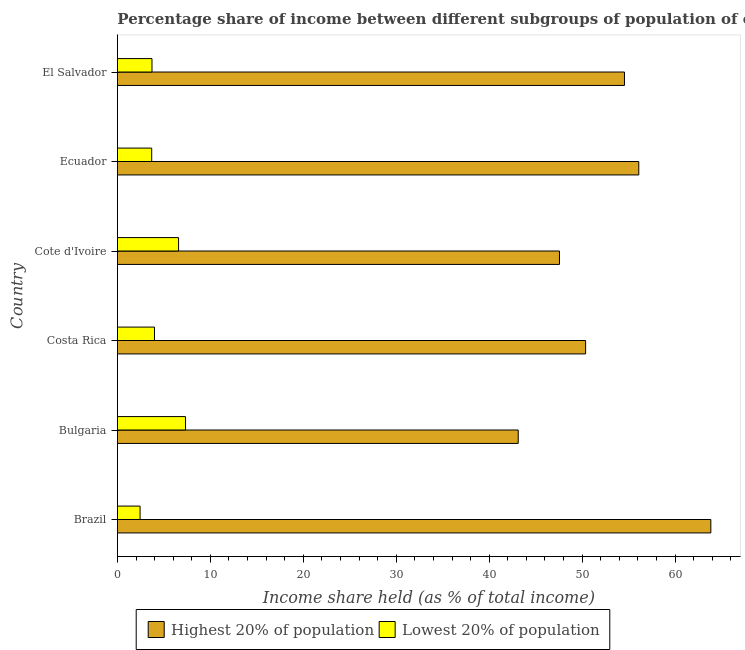How many different coloured bars are there?
Your answer should be very brief. 2. How many groups of bars are there?
Your response must be concise. 6. How many bars are there on the 3rd tick from the top?
Provide a short and direct response. 2. How many bars are there on the 4th tick from the bottom?
Give a very brief answer. 2. In how many cases, is the number of bars for a given country not equal to the number of legend labels?
Make the answer very short. 0. What is the income share held by lowest 20% of the population in Bulgaria?
Make the answer very short. 7.33. Across all countries, what is the maximum income share held by lowest 20% of the population?
Your answer should be compact. 7.33. Across all countries, what is the minimum income share held by lowest 20% of the population?
Keep it short and to the point. 2.44. In which country was the income share held by highest 20% of the population maximum?
Make the answer very short. Brazil. In which country was the income share held by highest 20% of the population minimum?
Ensure brevity in your answer.  Bulgaria. What is the total income share held by lowest 20% of the population in the graph?
Offer a terse response. 27.75. What is the difference between the income share held by highest 20% of the population in Bulgaria and that in El Salvador?
Give a very brief answer. -11.43. What is the difference between the income share held by lowest 20% of the population in Bulgaria and the income share held by highest 20% of the population in El Salvador?
Make the answer very short. -47.22. What is the average income share held by lowest 20% of the population per country?
Your answer should be compact. 4.62. What is the difference between the income share held by lowest 20% of the population and income share held by highest 20% of the population in Bulgaria?
Your answer should be very brief. -35.79. What is the ratio of the income share held by highest 20% of the population in Costa Rica to that in El Salvador?
Ensure brevity in your answer.  0.92. What is the difference between the highest and the lowest income share held by lowest 20% of the population?
Your response must be concise. 4.89. What does the 2nd bar from the top in Cote d'Ivoire represents?
Make the answer very short. Highest 20% of population. What does the 1st bar from the bottom in Cote d'Ivoire represents?
Give a very brief answer. Highest 20% of population. Are all the bars in the graph horizontal?
Keep it short and to the point. Yes. Are the values on the major ticks of X-axis written in scientific E-notation?
Your response must be concise. No. Where does the legend appear in the graph?
Your answer should be compact. Bottom center. What is the title of the graph?
Provide a succinct answer. Percentage share of income between different subgroups of population of countries. Does "Quasi money growth" appear as one of the legend labels in the graph?
Your response must be concise. No. What is the label or title of the X-axis?
Ensure brevity in your answer.  Income share held (as % of total income). What is the Income share held (as % of total income) of Highest 20% of population in Brazil?
Make the answer very short. 63.84. What is the Income share held (as % of total income) of Lowest 20% of population in Brazil?
Offer a terse response. 2.44. What is the Income share held (as % of total income) of Highest 20% of population in Bulgaria?
Your answer should be compact. 43.12. What is the Income share held (as % of total income) of Lowest 20% of population in Bulgaria?
Your answer should be compact. 7.33. What is the Income share held (as % of total income) of Highest 20% of population in Costa Rica?
Give a very brief answer. 50.37. What is the Income share held (as % of total income) of Lowest 20% of population in Costa Rica?
Offer a terse response. 3.99. What is the Income share held (as % of total income) in Highest 20% of population in Cote d'Ivoire?
Keep it short and to the point. 47.56. What is the Income share held (as % of total income) in Lowest 20% of population in Cote d'Ivoire?
Offer a very short reply. 6.58. What is the Income share held (as % of total income) of Highest 20% of population in Ecuador?
Your answer should be very brief. 56.09. What is the Income share held (as % of total income) in Lowest 20% of population in Ecuador?
Your response must be concise. 3.69. What is the Income share held (as % of total income) of Highest 20% of population in El Salvador?
Offer a very short reply. 54.55. What is the Income share held (as % of total income) of Lowest 20% of population in El Salvador?
Provide a succinct answer. 3.72. Across all countries, what is the maximum Income share held (as % of total income) in Highest 20% of population?
Ensure brevity in your answer.  63.84. Across all countries, what is the maximum Income share held (as % of total income) of Lowest 20% of population?
Your answer should be very brief. 7.33. Across all countries, what is the minimum Income share held (as % of total income) in Highest 20% of population?
Ensure brevity in your answer.  43.12. Across all countries, what is the minimum Income share held (as % of total income) of Lowest 20% of population?
Make the answer very short. 2.44. What is the total Income share held (as % of total income) of Highest 20% of population in the graph?
Give a very brief answer. 315.53. What is the total Income share held (as % of total income) of Lowest 20% of population in the graph?
Provide a succinct answer. 27.75. What is the difference between the Income share held (as % of total income) of Highest 20% of population in Brazil and that in Bulgaria?
Your answer should be compact. 20.72. What is the difference between the Income share held (as % of total income) in Lowest 20% of population in Brazil and that in Bulgaria?
Provide a short and direct response. -4.89. What is the difference between the Income share held (as % of total income) in Highest 20% of population in Brazil and that in Costa Rica?
Ensure brevity in your answer.  13.47. What is the difference between the Income share held (as % of total income) in Lowest 20% of population in Brazil and that in Costa Rica?
Keep it short and to the point. -1.55. What is the difference between the Income share held (as % of total income) of Highest 20% of population in Brazil and that in Cote d'Ivoire?
Offer a terse response. 16.28. What is the difference between the Income share held (as % of total income) in Lowest 20% of population in Brazil and that in Cote d'Ivoire?
Offer a very short reply. -4.14. What is the difference between the Income share held (as % of total income) of Highest 20% of population in Brazil and that in Ecuador?
Provide a succinct answer. 7.75. What is the difference between the Income share held (as % of total income) in Lowest 20% of population in Brazil and that in Ecuador?
Provide a succinct answer. -1.25. What is the difference between the Income share held (as % of total income) of Highest 20% of population in Brazil and that in El Salvador?
Keep it short and to the point. 9.29. What is the difference between the Income share held (as % of total income) of Lowest 20% of population in Brazil and that in El Salvador?
Keep it short and to the point. -1.28. What is the difference between the Income share held (as % of total income) of Highest 20% of population in Bulgaria and that in Costa Rica?
Keep it short and to the point. -7.25. What is the difference between the Income share held (as % of total income) in Lowest 20% of population in Bulgaria and that in Costa Rica?
Your answer should be very brief. 3.34. What is the difference between the Income share held (as % of total income) of Highest 20% of population in Bulgaria and that in Cote d'Ivoire?
Your answer should be very brief. -4.44. What is the difference between the Income share held (as % of total income) in Highest 20% of population in Bulgaria and that in Ecuador?
Offer a very short reply. -12.97. What is the difference between the Income share held (as % of total income) of Lowest 20% of population in Bulgaria and that in Ecuador?
Give a very brief answer. 3.64. What is the difference between the Income share held (as % of total income) of Highest 20% of population in Bulgaria and that in El Salvador?
Keep it short and to the point. -11.43. What is the difference between the Income share held (as % of total income) in Lowest 20% of population in Bulgaria and that in El Salvador?
Provide a short and direct response. 3.61. What is the difference between the Income share held (as % of total income) of Highest 20% of population in Costa Rica and that in Cote d'Ivoire?
Offer a very short reply. 2.81. What is the difference between the Income share held (as % of total income) of Lowest 20% of population in Costa Rica and that in Cote d'Ivoire?
Keep it short and to the point. -2.59. What is the difference between the Income share held (as % of total income) in Highest 20% of population in Costa Rica and that in Ecuador?
Provide a short and direct response. -5.72. What is the difference between the Income share held (as % of total income) in Lowest 20% of population in Costa Rica and that in Ecuador?
Your answer should be compact. 0.3. What is the difference between the Income share held (as % of total income) in Highest 20% of population in Costa Rica and that in El Salvador?
Offer a very short reply. -4.18. What is the difference between the Income share held (as % of total income) of Lowest 20% of population in Costa Rica and that in El Salvador?
Give a very brief answer. 0.27. What is the difference between the Income share held (as % of total income) of Highest 20% of population in Cote d'Ivoire and that in Ecuador?
Keep it short and to the point. -8.53. What is the difference between the Income share held (as % of total income) in Lowest 20% of population in Cote d'Ivoire and that in Ecuador?
Your answer should be compact. 2.89. What is the difference between the Income share held (as % of total income) in Highest 20% of population in Cote d'Ivoire and that in El Salvador?
Your answer should be compact. -6.99. What is the difference between the Income share held (as % of total income) in Lowest 20% of population in Cote d'Ivoire and that in El Salvador?
Make the answer very short. 2.86. What is the difference between the Income share held (as % of total income) of Highest 20% of population in Ecuador and that in El Salvador?
Your answer should be very brief. 1.54. What is the difference between the Income share held (as % of total income) in Lowest 20% of population in Ecuador and that in El Salvador?
Ensure brevity in your answer.  -0.03. What is the difference between the Income share held (as % of total income) in Highest 20% of population in Brazil and the Income share held (as % of total income) in Lowest 20% of population in Bulgaria?
Offer a terse response. 56.51. What is the difference between the Income share held (as % of total income) of Highest 20% of population in Brazil and the Income share held (as % of total income) of Lowest 20% of population in Costa Rica?
Ensure brevity in your answer.  59.85. What is the difference between the Income share held (as % of total income) in Highest 20% of population in Brazil and the Income share held (as % of total income) in Lowest 20% of population in Cote d'Ivoire?
Your answer should be compact. 57.26. What is the difference between the Income share held (as % of total income) in Highest 20% of population in Brazil and the Income share held (as % of total income) in Lowest 20% of population in Ecuador?
Offer a terse response. 60.15. What is the difference between the Income share held (as % of total income) in Highest 20% of population in Brazil and the Income share held (as % of total income) in Lowest 20% of population in El Salvador?
Your answer should be very brief. 60.12. What is the difference between the Income share held (as % of total income) of Highest 20% of population in Bulgaria and the Income share held (as % of total income) of Lowest 20% of population in Costa Rica?
Ensure brevity in your answer.  39.13. What is the difference between the Income share held (as % of total income) of Highest 20% of population in Bulgaria and the Income share held (as % of total income) of Lowest 20% of population in Cote d'Ivoire?
Your answer should be very brief. 36.54. What is the difference between the Income share held (as % of total income) of Highest 20% of population in Bulgaria and the Income share held (as % of total income) of Lowest 20% of population in Ecuador?
Keep it short and to the point. 39.43. What is the difference between the Income share held (as % of total income) in Highest 20% of population in Bulgaria and the Income share held (as % of total income) in Lowest 20% of population in El Salvador?
Your answer should be compact. 39.4. What is the difference between the Income share held (as % of total income) of Highest 20% of population in Costa Rica and the Income share held (as % of total income) of Lowest 20% of population in Cote d'Ivoire?
Your answer should be very brief. 43.79. What is the difference between the Income share held (as % of total income) in Highest 20% of population in Costa Rica and the Income share held (as % of total income) in Lowest 20% of population in Ecuador?
Provide a short and direct response. 46.68. What is the difference between the Income share held (as % of total income) in Highest 20% of population in Costa Rica and the Income share held (as % of total income) in Lowest 20% of population in El Salvador?
Your response must be concise. 46.65. What is the difference between the Income share held (as % of total income) of Highest 20% of population in Cote d'Ivoire and the Income share held (as % of total income) of Lowest 20% of population in Ecuador?
Your answer should be very brief. 43.87. What is the difference between the Income share held (as % of total income) in Highest 20% of population in Cote d'Ivoire and the Income share held (as % of total income) in Lowest 20% of population in El Salvador?
Provide a short and direct response. 43.84. What is the difference between the Income share held (as % of total income) in Highest 20% of population in Ecuador and the Income share held (as % of total income) in Lowest 20% of population in El Salvador?
Keep it short and to the point. 52.37. What is the average Income share held (as % of total income) of Highest 20% of population per country?
Offer a terse response. 52.59. What is the average Income share held (as % of total income) in Lowest 20% of population per country?
Offer a terse response. 4.62. What is the difference between the Income share held (as % of total income) of Highest 20% of population and Income share held (as % of total income) of Lowest 20% of population in Brazil?
Make the answer very short. 61.4. What is the difference between the Income share held (as % of total income) in Highest 20% of population and Income share held (as % of total income) in Lowest 20% of population in Bulgaria?
Provide a succinct answer. 35.79. What is the difference between the Income share held (as % of total income) of Highest 20% of population and Income share held (as % of total income) of Lowest 20% of population in Costa Rica?
Provide a short and direct response. 46.38. What is the difference between the Income share held (as % of total income) of Highest 20% of population and Income share held (as % of total income) of Lowest 20% of population in Cote d'Ivoire?
Your answer should be compact. 40.98. What is the difference between the Income share held (as % of total income) in Highest 20% of population and Income share held (as % of total income) in Lowest 20% of population in Ecuador?
Provide a short and direct response. 52.4. What is the difference between the Income share held (as % of total income) of Highest 20% of population and Income share held (as % of total income) of Lowest 20% of population in El Salvador?
Your response must be concise. 50.83. What is the ratio of the Income share held (as % of total income) of Highest 20% of population in Brazil to that in Bulgaria?
Your answer should be compact. 1.48. What is the ratio of the Income share held (as % of total income) of Lowest 20% of population in Brazil to that in Bulgaria?
Provide a succinct answer. 0.33. What is the ratio of the Income share held (as % of total income) of Highest 20% of population in Brazil to that in Costa Rica?
Provide a short and direct response. 1.27. What is the ratio of the Income share held (as % of total income) of Lowest 20% of population in Brazil to that in Costa Rica?
Provide a short and direct response. 0.61. What is the ratio of the Income share held (as % of total income) in Highest 20% of population in Brazil to that in Cote d'Ivoire?
Keep it short and to the point. 1.34. What is the ratio of the Income share held (as % of total income) of Lowest 20% of population in Brazil to that in Cote d'Ivoire?
Your response must be concise. 0.37. What is the ratio of the Income share held (as % of total income) of Highest 20% of population in Brazil to that in Ecuador?
Offer a very short reply. 1.14. What is the ratio of the Income share held (as % of total income) in Lowest 20% of population in Brazil to that in Ecuador?
Your answer should be very brief. 0.66. What is the ratio of the Income share held (as % of total income) of Highest 20% of population in Brazil to that in El Salvador?
Provide a succinct answer. 1.17. What is the ratio of the Income share held (as % of total income) in Lowest 20% of population in Brazil to that in El Salvador?
Offer a terse response. 0.66. What is the ratio of the Income share held (as % of total income) of Highest 20% of population in Bulgaria to that in Costa Rica?
Provide a short and direct response. 0.86. What is the ratio of the Income share held (as % of total income) in Lowest 20% of population in Bulgaria to that in Costa Rica?
Offer a very short reply. 1.84. What is the ratio of the Income share held (as % of total income) in Highest 20% of population in Bulgaria to that in Cote d'Ivoire?
Provide a short and direct response. 0.91. What is the ratio of the Income share held (as % of total income) in Lowest 20% of population in Bulgaria to that in Cote d'Ivoire?
Your response must be concise. 1.11. What is the ratio of the Income share held (as % of total income) of Highest 20% of population in Bulgaria to that in Ecuador?
Offer a very short reply. 0.77. What is the ratio of the Income share held (as % of total income) in Lowest 20% of population in Bulgaria to that in Ecuador?
Offer a very short reply. 1.99. What is the ratio of the Income share held (as % of total income) in Highest 20% of population in Bulgaria to that in El Salvador?
Your answer should be very brief. 0.79. What is the ratio of the Income share held (as % of total income) of Lowest 20% of population in Bulgaria to that in El Salvador?
Make the answer very short. 1.97. What is the ratio of the Income share held (as % of total income) of Highest 20% of population in Costa Rica to that in Cote d'Ivoire?
Give a very brief answer. 1.06. What is the ratio of the Income share held (as % of total income) in Lowest 20% of population in Costa Rica to that in Cote d'Ivoire?
Provide a succinct answer. 0.61. What is the ratio of the Income share held (as % of total income) in Highest 20% of population in Costa Rica to that in Ecuador?
Give a very brief answer. 0.9. What is the ratio of the Income share held (as % of total income) in Lowest 20% of population in Costa Rica to that in Ecuador?
Provide a short and direct response. 1.08. What is the ratio of the Income share held (as % of total income) in Highest 20% of population in Costa Rica to that in El Salvador?
Offer a very short reply. 0.92. What is the ratio of the Income share held (as % of total income) in Lowest 20% of population in Costa Rica to that in El Salvador?
Provide a succinct answer. 1.07. What is the ratio of the Income share held (as % of total income) in Highest 20% of population in Cote d'Ivoire to that in Ecuador?
Give a very brief answer. 0.85. What is the ratio of the Income share held (as % of total income) in Lowest 20% of population in Cote d'Ivoire to that in Ecuador?
Offer a very short reply. 1.78. What is the ratio of the Income share held (as % of total income) in Highest 20% of population in Cote d'Ivoire to that in El Salvador?
Keep it short and to the point. 0.87. What is the ratio of the Income share held (as % of total income) in Lowest 20% of population in Cote d'Ivoire to that in El Salvador?
Ensure brevity in your answer.  1.77. What is the ratio of the Income share held (as % of total income) of Highest 20% of population in Ecuador to that in El Salvador?
Ensure brevity in your answer.  1.03. What is the ratio of the Income share held (as % of total income) in Lowest 20% of population in Ecuador to that in El Salvador?
Keep it short and to the point. 0.99. What is the difference between the highest and the second highest Income share held (as % of total income) of Highest 20% of population?
Make the answer very short. 7.75. What is the difference between the highest and the lowest Income share held (as % of total income) in Highest 20% of population?
Keep it short and to the point. 20.72. What is the difference between the highest and the lowest Income share held (as % of total income) of Lowest 20% of population?
Provide a succinct answer. 4.89. 